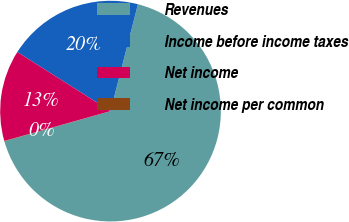Convert chart to OTSL. <chart><loc_0><loc_0><loc_500><loc_500><pie_chart><fcel>Revenues<fcel>Income before income taxes<fcel>Net income<fcel>Net income per common<nl><fcel>66.59%<fcel>20.01%<fcel>13.35%<fcel>0.05%<nl></chart> 